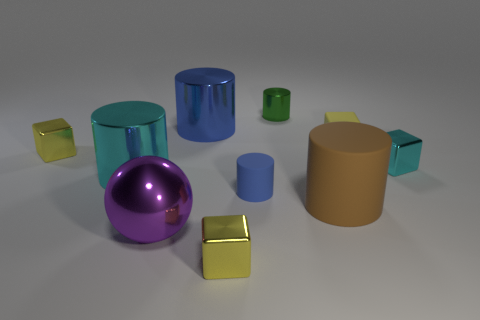What is the color of the large ball that is the same material as the tiny cyan block? purple 